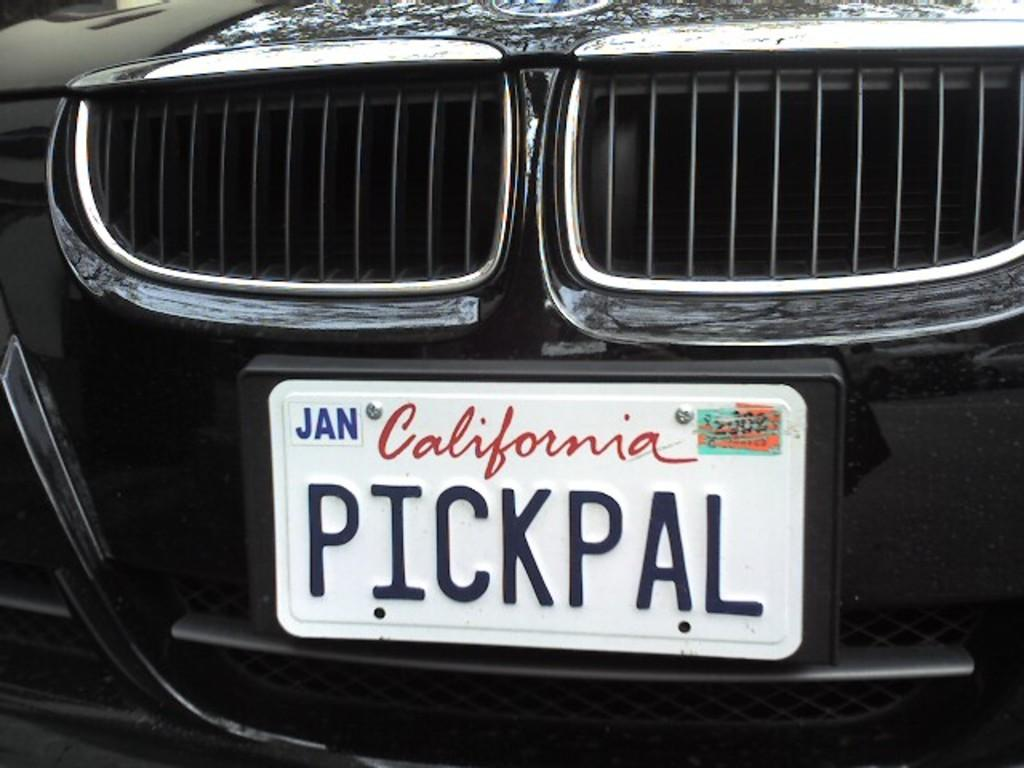<image>
Offer a succinct explanation of the picture presented. The California license plate has Pickpal written on it. 